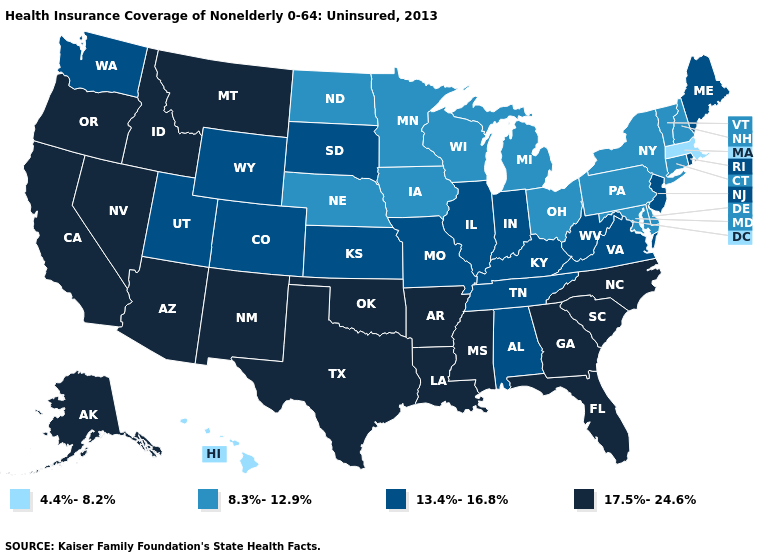Does Massachusetts have the lowest value in the Northeast?
Write a very short answer. Yes. What is the value of Wyoming?
Quick response, please. 13.4%-16.8%. Name the states that have a value in the range 8.3%-12.9%?
Keep it brief. Connecticut, Delaware, Iowa, Maryland, Michigan, Minnesota, Nebraska, New Hampshire, New York, North Dakota, Ohio, Pennsylvania, Vermont, Wisconsin. What is the value of Minnesota?
Keep it brief. 8.3%-12.9%. What is the lowest value in the USA?
Quick response, please. 4.4%-8.2%. Name the states that have a value in the range 17.5%-24.6%?
Write a very short answer. Alaska, Arizona, Arkansas, California, Florida, Georgia, Idaho, Louisiana, Mississippi, Montana, Nevada, New Mexico, North Carolina, Oklahoma, Oregon, South Carolina, Texas. Does Washington have the lowest value in the West?
Keep it brief. No. Name the states that have a value in the range 4.4%-8.2%?
Concise answer only. Hawaii, Massachusetts. Name the states that have a value in the range 17.5%-24.6%?
Quick response, please. Alaska, Arizona, Arkansas, California, Florida, Georgia, Idaho, Louisiana, Mississippi, Montana, Nevada, New Mexico, North Carolina, Oklahoma, Oregon, South Carolina, Texas. What is the lowest value in states that border New Jersey?
Keep it brief. 8.3%-12.9%. Name the states that have a value in the range 4.4%-8.2%?
Be succinct. Hawaii, Massachusetts. What is the highest value in the USA?
Keep it brief. 17.5%-24.6%. Name the states that have a value in the range 8.3%-12.9%?
Write a very short answer. Connecticut, Delaware, Iowa, Maryland, Michigan, Minnesota, Nebraska, New Hampshire, New York, North Dakota, Ohio, Pennsylvania, Vermont, Wisconsin. Name the states that have a value in the range 8.3%-12.9%?
Give a very brief answer. Connecticut, Delaware, Iowa, Maryland, Michigan, Minnesota, Nebraska, New Hampshire, New York, North Dakota, Ohio, Pennsylvania, Vermont, Wisconsin. Name the states that have a value in the range 17.5%-24.6%?
Answer briefly. Alaska, Arizona, Arkansas, California, Florida, Georgia, Idaho, Louisiana, Mississippi, Montana, Nevada, New Mexico, North Carolina, Oklahoma, Oregon, South Carolina, Texas. 